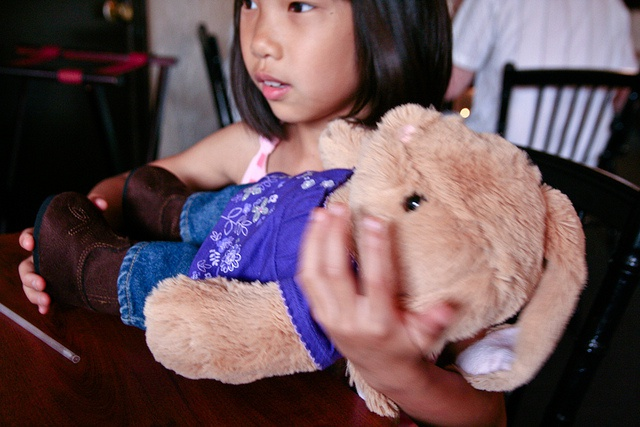Describe the objects in this image and their specific colors. I can see teddy bear in black, lightpink, darkgray, and brown tones, people in black, lightpink, brown, and maroon tones, dining table in black, maroon, and gray tones, people in black, darkgray, and lavender tones, and chair in black, gray, maroon, and darkgray tones in this image. 